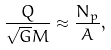<formula> <loc_0><loc_0><loc_500><loc_500>\frac { Q } { \sqrt { G } M } \approx \frac { N _ { p } } { A } ,</formula> 